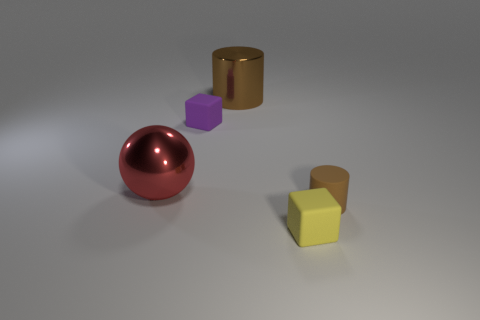There is a metallic object that is the same color as the rubber cylinder; what shape is it?
Provide a short and direct response. Cylinder. What is the small object to the left of the big metallic cylinder made of?
Your answer should be compact. Rubber. The metal cylinder has what size?
Ensure brevity in your answer.  Large. Is the small cube to the left of the large brown shiny cylinder made of the same material as the small yellow cube?
Your answer should be compact. Yes. What number of metal cylinders are there?
Keep it short and to the point. 1. What number of things are either small purple things or brown matte cylinders?
Make the answer very short. 2. There is a rubber cube that is to the left of the small rubber thing that is in front of the small cylinder; how many matte objects are to the left of it?
Give a very brief answer. 0. Is there any other thing that has the same color as the metal cylinder?
Your answer should be compact. Yes. Is the color of the shiny object that is in front of the brown shiny cylinder the same as the rubber block that is behind the big red metal object?
Make the answer very short. No. Are there more large brown metallic cylinders in front of the big red ball than large brown cylinders that are behind the yellow rubber cube?
Make the answer very short. No. 